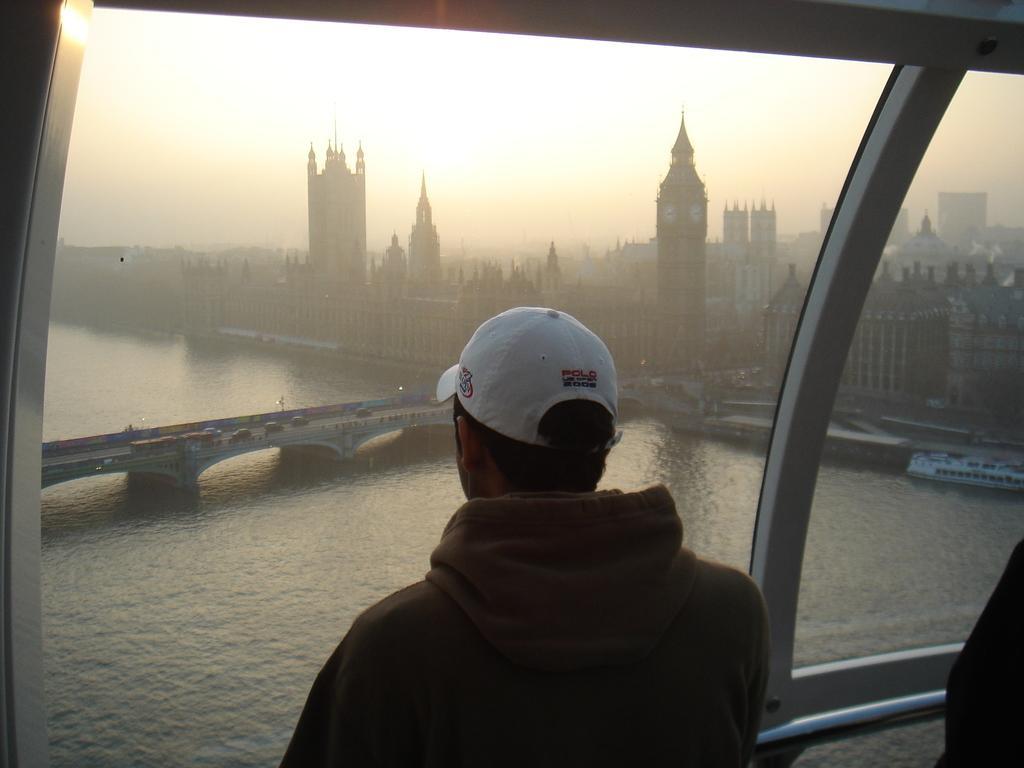Can you describe this image briefly? This image consists of building in the middle. There is a bridge in the middle. There are some persons standing in the middle. There is sky at the top. 